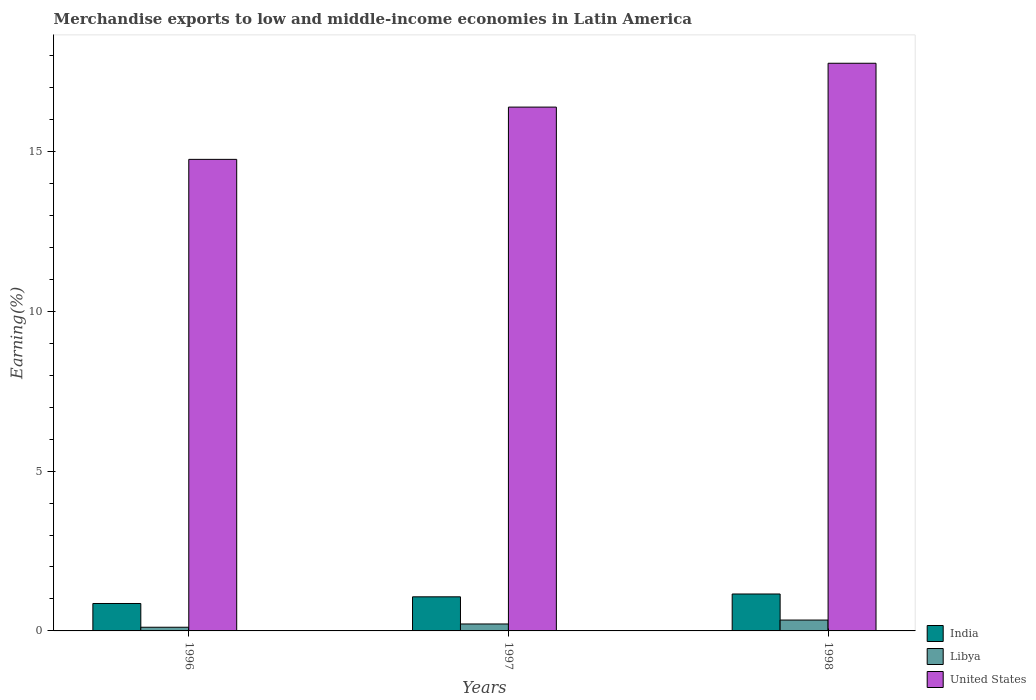How many different coloured bars are there?
Provide a succinct answer. 3. How many bars are there on the 3rd tick from the left?
Provide a succinct answer. 3. How many bars are there on the 3rd tick from the right?
Give a very brief answer. 3. What is the label of the 1st group of bars from the left?
Offer a very short reply. 1996. What is the percentage of amount earned from merchandise exports in Libya in 1997?
Provide a short and direct response. 0.22. Across all years, what is the maximum percentage of amount earned from merchandise exports in India?
Your answer should be very brief. 1.15. Across all years, what is the minimum percentage of amount earned from merchandise exports in India?
Offer a very short reply. 0.86. In which year was the percentage of amount earned from merchandise exports in Libya minimum?
Provide a succinct answer. 1996. What is the total percentage of amount earned from merchandise exports in India in the graph?
Provide a succinct answer. 3.08. What is the difference between the percentage of amount earned from merchandise exports in Libya in 1997 and that in 1998?
Offer a terse response. -0.12. What is the difference between the percentage of amount earned from merchandise exports in United States in 1998 and the percentage of amount earned from merchandise exports in Libya in 1996?
Offer a very short reply. 17.64. What is the average percentage of amount earned from merchandise exports in United States per year?
Keep it short and to the point. 16.3. In the year 1997, what is the difference between the percentage of amount earned from merchandise exports in United States and percentage of amount earned from merchandise exports in Libya?
Your answer should be very brief. 16.17. What is the ratio of the percentage of amount earned from merchandise exports in Libya in 1997 to that in 1998?
Provide a succinct answer. 0.64. What is the difference between the highest and the second highest percentage of amount earned from merchandise exports in India?
Offer a very short reply. 0.09. What is the difference between the highest and the lowest percentage of amount earned from merchandise exports in United States?
Keep it short and to the point. 3.01. Is the sum of the percentage of amount earned from merchandise exports in India in 1997 and 1998 greater than the maximum percentage of amount earned from merchandise exports in United States across all years?
Ensure brevity in your answer.  No. What does the 2nd bar from the left in 1998 represents?
Offer a terse response. Libya. Is it the case that in every year, the sum of the percentage of amount earned from merchandise exports in United States and percentage of amount earned from merchandise exports in India is greater than the percentage of amount earned from merchandise exports in Libya?
Your answer should be compact. Yes. How many bars are there?
Keep it short and to the point. 9. Are all the bars in the graph horizontal?
Your answer should be compact. No. How are the legend labels stacked?
Offer a very short reply. Vertical. What is the title of the graph?
Your answer should be very brief. Merchandise exports to low and middle-income economies in Latin America. Does "Yemen, Rep." appear as one of the legend labels in the graph?
Make the answer very short. No. What is the label or title of the X-axis?
Offer a very short reply. Years. What is the label or title of the Y-axis?
Your answer should be very brief. Earning(%). What is the Earning(%) of India in 1996?
Ensure brevity in your answer.  0.86. What is the Earning(%) of Libya in 1996?
Provide a succinct answer. 0.11. What is the Earning(%) of United States in 1996?
Make the answer very short. 14.75. What is the Earning(%) in India in 1997?
Your answer should be compact. 1.07. What is the Earning(%) of Libya in 1997?
Provide a short and direct response. 0.22. What is the Earning(%) of United States in 1997?
Keep it short and to the point. 16.39. What is the Earning(%) of India in 1998?
Your answer should be very brief. 1.15. What is the Earning(%) of Libya in 1998?
Ensure brevity in your answer.  0.34. What is the Earning(%) of United States in 1998?
Provide a succinct answer. 17.76. Across all years, what is the maximum Earning(%) of India?
Your response must be concise. 1.15. Across all years, what is the maximum Earning(%) of Libya?
Make the answer very short. 0.34. Across all years, what is the maximum Earning(%) in United States?
Offer a terse response. 17.76. Across all years, what is the minimum Earning(%) in India?
Your answer should be very brief. 0.86. Across all years, what is the minimum Earning(%) in Libya?
Offer a terse response. 0.11. Across all years, what is the minimum Earning(%) of United States?
Provide a succinct answer. 14.75. What is the total Earning(%) of India in the graph?
Offer a very short reply. 3.08. What is the total Earning(%) of Libya in the graph?
Offer a very short reply. 0.67. What is the total Earning(%) of United States in the graph?
Your answer should be compact. 48.89. What is the difference between the Earning(%) of India in 1996 and that in 1997?
Ensure brevity in your answer.  -0.21. What is the difference between the Earning(%) in Libya in 1996 and that in 1997?
Offer a very short reply. -0.1. What is the difference between the Earning(%) in United States in 1996 and that in 1997?
Ensure brevity in your answer.  -1.63. What is the difference between the Earning(%) in India in 1996 and that in 1998?
Make the answer very short. -0.3. What is the difference between the Earning(%) in Libya in 1996 and that in 1998?
Provide a succinct answer. -0.22. What is the difference between the Earning(%) in United States in 1996 and that in 1998?
Give a very brief answer. -3.01. What is the difference between the Earning(%) of India in 1997 and that in 1998?
Your answer should be compact. -0.09. What is the difference between the Earning(%) in Libya in 1997 and that in 1998?
Make the answer very short. -0.12. What is the difference between the Earning(%) of United States in 1997 and that in 1998?
Provide a succinct answer. -1.37. What is the difference between the Earning(%) in India in 1996 and the Earning(%) in Libya in 1997?
Keep it short and to the point. 0.64. What is the difference between the Earning(%) in India in 1996 and the Earning(%) in United States in 1997?
Make the answer very short. -15.53. What is the difference between the Earning(%) in Libya in 1996 and the Earning(%) in United States in 1997?
Offer a terse response. -16.27. What is the difference between the Earning(%) of India in 1996 and the Earning(%) of Libya in 1998?
Your response must be concise. 0.52. What is the difference between the Earning(%) of India in 1996 and the Earning(%) of United States in 1998?
Give a very brief answer. -16.9. What is the difference between the Earning(%) of Libya in 1996 and the Earning(%) of United States in 1998?
Provide a short and direct response. -17.64. What is the difference between the Earning(%) of India in 1997 and the Earning(%) of Libya in 1998?
Offer a terse response. 0.73. What is the difference between the Earning(%) of India in 1997 and the Earning(%) of United States in 1998?
Ensure brevity in your answer.  -16.69. What is the difference between the Earning(%) of Libya in 1997 and the Earning(%) of United States in 1998?
Offer a very short reply. -17.54. What is the average Earning(%) in India per year?
Your answer should be very brief. 1.03. What is the average Earning(%) of Libya per year?
Offer a very short reply. 0.22. What is the average Earning(%) of United States per year?
Provide a short and direct response. 16.3. In the year 1996, what is the difference between the Earning(%) of India and Earning(%) of Libya?
Offer a terse response. 0.74. In the year 1996, what is the difference between the Earning(%) of India and Earning(%) of United States?
Offer a very short reply. -13.89. In the year 1996, what is the difference between the Earning(%) in Libya and Earning(%) in United States?
Offer a very short reply. -14.64. In the year 1997, what is the difference between the Earning(%) of India and Earning(%) of Libya?
Keep it short and to the point. 0.85. In the year 1997, what is the difference between the Earning(%) in India and Earning(%) in United States?
Your response must be concise. -15.32. In the year 1997, what is the difference between the Earning(%) of Libya and Earning(%) of United States?
Provide a short and direct response. -16.17. In the year 1998, what is the difference between the Earning(%) in India and Earning(%) in Libya?
Provide a succinct answer. 0.81. In the year 1998, what is the difference between the Earning(%) in India and Earning(%) in United States?
Offer a terse response. -16.6. In the year 1998, what is the difference between the Earning(%) of Libya and Earning(%) of United States?
Provide a short and direct response. -17.42. What is the ratio of the Earning(%) in India in 1996 to that in 1997?
Give a very brief answer. 0.8. What is the ratio of the Earning(%) of Libya in 1996 to that in 1997?
Ensure brevity in your answer.  0.53. What is the ratio of the Earning(%) of United States in 1996 to that in 1997?
Your answer should be compact. 0.9. What is the ratio of the Earning(%) in India in 1996 to that in 1998?
Provide a succinct answer. 0.74. What is the ratio of the Earning(%) of Libya in 1996 to that in 1998?
Your answer should be compact. 0.34. What is the ratio of the Earning(%) in United States in 1996 to that in 1998?
Your response must be concise. 0.83. What is the ratio of the Earning(%) in India in 1997 to that in 1998?
Make the answer very short. 0.92. What is the ratio of the Earning(%) in Libya in 1997 to that in 1998?
Offer a terse response. 0.64. What is the ratio of the Earning(%) in United States in 1997 to that in 1998?
Your answer should be compact. 0.92. What is the difference between the highest and the second highest Earning(%) of India?
Make the answer very short. 0.09. What is the difference between the highest and the second highest Earning(%) of Libya?
Provide a short and direct response. 0.12. What is the difference between the highest and the second highest Earning(%) in United States?
Make the answer very short. 1.37. What is the difference between the highest and the lowest Earning(%) in India?
Offer a very short reply. 0.3. What is the difference between the highest and the lowest Earning(%) in Libya?
Offer a terse response. 0.22. What is the difference between the highest and the lowest Earning(%) in United States?
Keep it short and to the point. 3.01. 